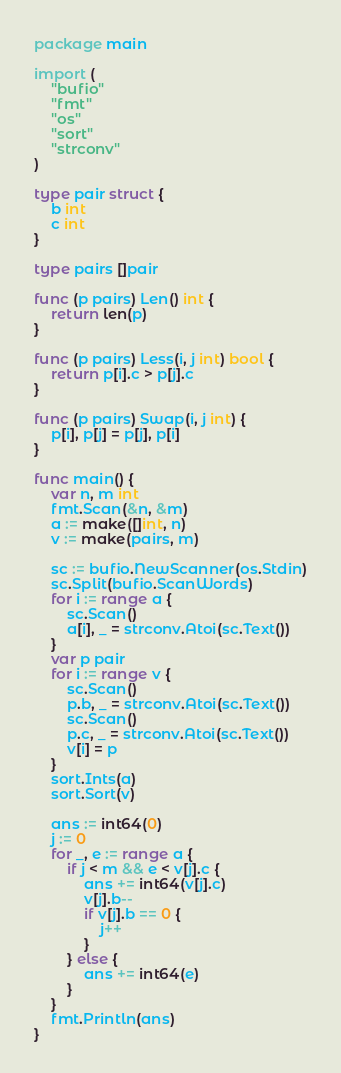<code> <loc_0><loc_0><loc_500><loc_500><_Go_>package main

import (
	"bufio"
	"fmt"
	"os"
	"sort"
	"strconv"
)

type pair struct {
	b int
	c int
}

type pairs []pair

func (p pairs) Len() int {
	return len(p)
}

func (p pairs) Less(i, j int) bool {
	return p[i].c > p[j].c
}

func (p pairs) Swap(i, j int) {
	p[i], p[j] = p[j], p[i]
}

func main() {
	var n, m int
	fmt.Scan(&n, &m)
	a := make([]int, n)
	v := make(pairs, m)

	sc := bufio.NewScanner(os.Stdin)
	sc.Split(bufio.ScanWords)
	for i := range a {
		sc.Scan()
		a[i], _ = strconv.Atoi(sc.Text())
	}
	var p pair
	for i := range v {
		sc.Scan()
		p.b, _ = strconv.Atoi(sc.Text())
		sc.Scan()
		p.c, _ = strconv.Atoi(sc.Text())
		v[i] = p
	}
	sort.Ints(a)
	sort.Sort(v)

	ans := int64(0)
	j := 0
	for _, e := range a {
		if j < m && e < v[j].c {
			ans += int64(v[j].c)
			v[j].b--
			if v[j].b == 0 {
				j++
			}
		} else {
			ans += int64(e)
		}
	}
	fmt.Println(ans)
}
</code> 